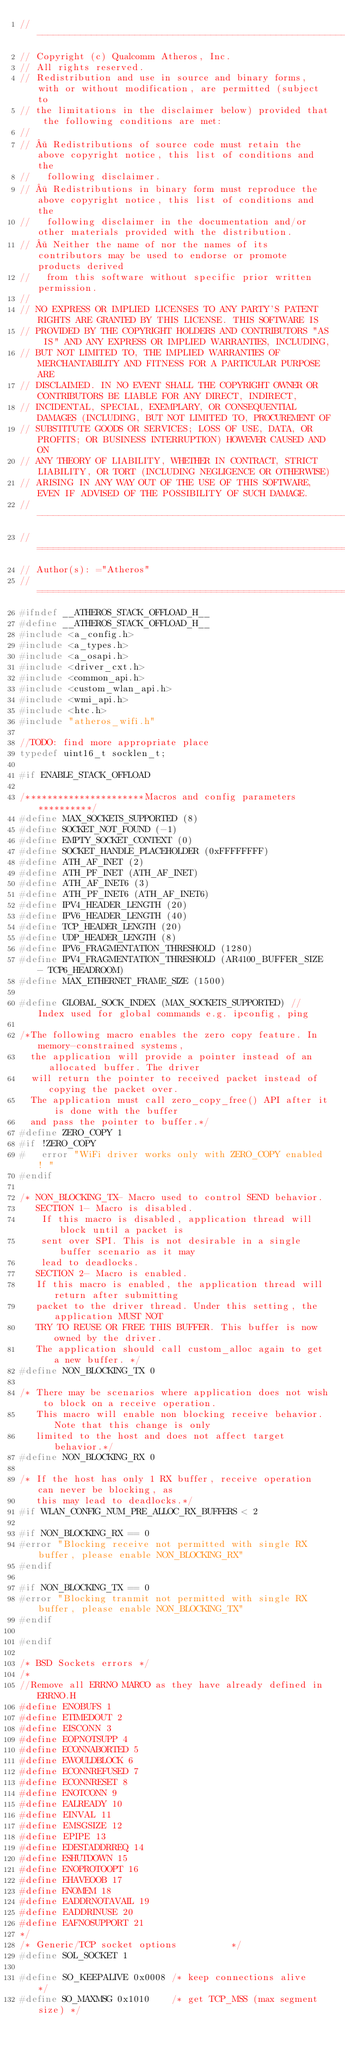Convert code to text. <code><loc_0><loc_0><loc_500><loc_500><_C_>//------------------------------------------------------------------------------
// Copyright (c) Qualcomm Atheros, Inc.
// All rights reserved.
// Redistribution and use in source and binary forms, with or without modification, are permitted (subject to
// the limitations in the disclaimer below) provided that the following conditions are met:
//
// · Redistributions of source code must retain the above copyright notice, this list of conditions and the
//   following disclaimer.
// · Redistributions in binary form must reproduce the above copyright notice, this list of conditions and the
//   following disclaimer in the documentation and/or other materials provided with the distribution.
// · Neither the name of nor the names of its contributors may be used to endorse or promote products derived
//   from this software without specific prior written permission.
//
// NO EXPRESS OR IMPLIED LICENSES TO ANY PARTY'S PATENT RIGHTS ARE GRANTED BY THIS LICENSE. THIS SOFTWARE IS
// PROVIDED BY THE COPYRIGHT HOLDERS AND CONTRIBUTORS "AS IS" AND ANY EXPRESS OR IMPLIED WARRANTIES, INCLUDING,
// BUT NOT LIMITED TO, THE IMPLIED WARRANTIES OF MERCHANTABILITY AND FITNESS FOR A PARTICULAR PURPOSE ARE
// DISCLAIMED. IN NO EVENT SHALL THE COPYRIGHT OWNER OR CONTRIBUTORS BE LIABLE FOR ANY DIRECT, INDIRECT,
// INCIDENTAL, SPECIAL, EXEMPLARY, OR CONSEQUENTIAL DAMAGES (INCLUDING, BUT NOT LIMITED TO, PROCUREMENT OF
// SUBSTITUTE GOODS OR SERVICES; LOSS OF USE, DATA, OR PROFITS; OR BUSINESS INTERRUPTION) HOWEVER CAUSED AND ON
// ANY THEORY OF LIABILITY, WHETHER IN CONTRACT, STRICT LIABILITY, OR TORT (INCLUDING NEGLIGENCE OR OTHERWISE)
// ARISING IN ANY WAY OUT OF THE USE OF THIS SOFTWARE, EVEN IF ADVISED OF THE POSSIBILITY OF SUCH DAMAGE.
//------------------------------------------------------------------------------
//==============================================================================
// Author(s): ="Atheros"
//==============================================================================
#ifndef __ATHEROS_STACK_OFFLOAD_H__
#define __ATHEROS_STACK_OFFLOAD_H__
#include <a_config.h>
#include <a_types.h>
#include <a_osapi.h>
#include <driver_cxt.h>
#include <common_api.h>
#include <custom_wlan_api.h>
#include <wmi_api.h>
#include <htc.h>
#include "atheros_wifi.h"

//TODO: find more appropriate place
typedef uint16_t socklen_t;

#if ENABLE_STACK_OFFLOAD

/**********************Macros and config parameters**********/
#define MAX_SOCKETS_SUPPORTED (8)
#define SOCKET_NOT_FOUND (-1)
#define EMPTY_SOCKET_CONTEXT (0)
#define SOCKET_HANDLE_PLACEHOLDER (0xFFFFFFFF)
#define ATH_AF_INET (2)
#define ATH_PF_INET (ATH_AF_INET)
#define ATH_AF_INET6 (3)
#define ATH_PF_INET6 (ATH_AF_INET6)
#define IPV4_HEADER_LENGTH (20)
#define IPV6_HEADER_LENGTH (40)
#define TCP_HEADER_LENGTH (20)
#define UDP_HEADER_LENGTH (8)
#define IPV6_FRAGMENTATION_THRESHOLD (1280)
#define IPV4_FRAGMENTATION_THRESHOLD (AR4100_BUFFER_SIZE - TCP6_HEADROOM)
#define MAX_ETHERNET_FRAME_SIZE (1500)

#define GLOBAL_SOCK_INDEX (MAX_SOCKETS_SUPPORTED) // Index used for global commands e.g. ipconfig, ping

/*The following macro enables the zero copy feature. In memory-constrained systems,
  the application will provide a pointer instead of an allocated buffer. The driver
  will return the pointer to received packet instead of copying the packet over.
  The application must call zero_copy_free() API after it is done with the buffer
  and pass the pointer to buffer.*/
#define ZERO_COPY 1
#if !ZERO_COPY
#   error "WiFi driver works only with ZERO_COPY enabled ! "
#endif

/* NON_BLOCKING_TX- Macro used to control SEND behavior.
   SECTION 1- Macro is disabled.
    If this macro is disabled, application thread will block until a packet is
    sent over SPI. This is not desirable in a single buffer scenario as it may
    lead to deadlocks.
   SECTION 2- Macro is enabled.
   If this macro is enabled, the application thread will return after submitting
   packet to the driver thread. Under this setting, the application MUST NOT
   TRY TO REUSE OR FREE THIS BUFFER. This buffer is now owned by the driver.
   The application should call custom_alloc again to get a new buffer. */
#define NON_BLOCKING_TX 0

/* There may be scenarios where application does not wish to block on a receive operation.
   This macro will enable non blocking receive behavior. Note that this change is only
   limited to the host and does not affect target behavior.*/
#define NON_BLOCKING_RX 0

/* If the host has only 1 RX buffer, receive operation can never be blocking, as
   this may lead to deadlocks.*/
#if WLAN_CONFIG_NUM_PRE_ALLOC_RX_BUFFERS < 2

#if NON_BLOCKING_RX == 0
#error "Blocking receive not permitted with single RX buffer, please enable NON_BLOCKING_RX"
#endif

#if NON_BLOCKING_TX == 0
#error "Blocking tranmit not permitted with single RX buffer, please enable NON_BLOCKING_TX"
#endif

#endif

/* BSD Sockets errors */
/*
//Remove all ERRNO MARCO as they have already defined in ERRNO.H
#define ENOBUFS 1
#define ETIMEDOUT 2
#define EISCONN 3
#define EOPNOTSUPP 4
#define ECONNABORTED 5
#define EWOULDBLOCK 6
#define ECONNREFUSED 7
#define ECONNRESET 8
#define ENOTCONN 9
#define EALREADY 10
#define EINVAL 11
#define EMSGSIZE 12
#define EPIPE 13
#define EDESTADDRREQ 14
#define ESHUTDOWN 15
#define ENOPROTOOPT 16
#define EHAVEOOB 17
#define ENOMEM 18
#define EADDRNOTAVAIL 19
#define EADDRINUSE 20
#define EAFNOSUPPORT 21
*/
/* Generic/TCP socket options          */
#define SOL_SOCKET 1

#define SO_KEEPALIVE 0x0008 /* keep connections alive    */
#define SO_MAXMSG 0x1010    /* get TCP_MSS (max segment size) */</code> 